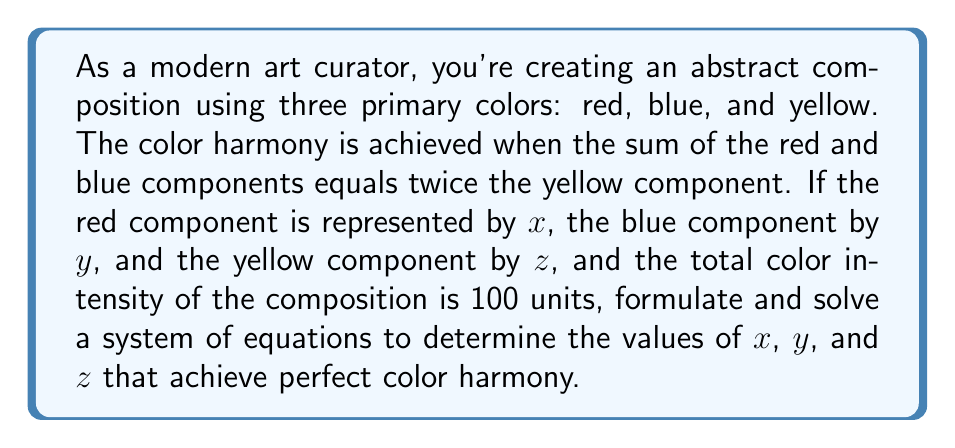Can you answer this question? Let's approach this step-by-step:

1) First, we can formulate two equations based on the given information:

   a) The sum of red and blue equals twice the yellow:
      $$x + y = 2z$$

   b) The total color intensity is 100 units:
      $$x + y + z = 100$$

2) Now we have a system of two equations with three unknowns. To solve this, we need one more equation. We can derive this from the concept of color harmony in abstract compositions, where often a balanced distribution is desired. Let's assume the blue component is the average of the red and yellow components:

   $$y = \frac{x + z}{2}$$

3) Now we have a system of three equations with three unknowns:

   $$\begin{cases}
   x + y = 2z \\
   x + y + z = 100 \\
   y = \frac{x + z}{2}
   \end{cases}$$

4) Substituting the third equation into the first:

   $$x + \frac{x + z}{2} = 2z$$

5) Simplifying:

   $$2x + x + z = 4z$$
   $$3x = 3z$$
   $$x = z$$

6) Substituting this back into the third equation:

   $$y = \frac{x + x}{2} = x$$

7) So we now know that $x = y = z$. Substituting this into the second equation:

   $$x + x + x = 100$$
   $$3x = 100$$
   $$x = \frac{100}{3} \approx 33.33$$

Therefore, the color components should each be approximately 33.33 units for perfect harmony in this abstract composition.
Answer: $x \approx 33.33$, $y \approx 33.33$, $z \approx 33.33$ 